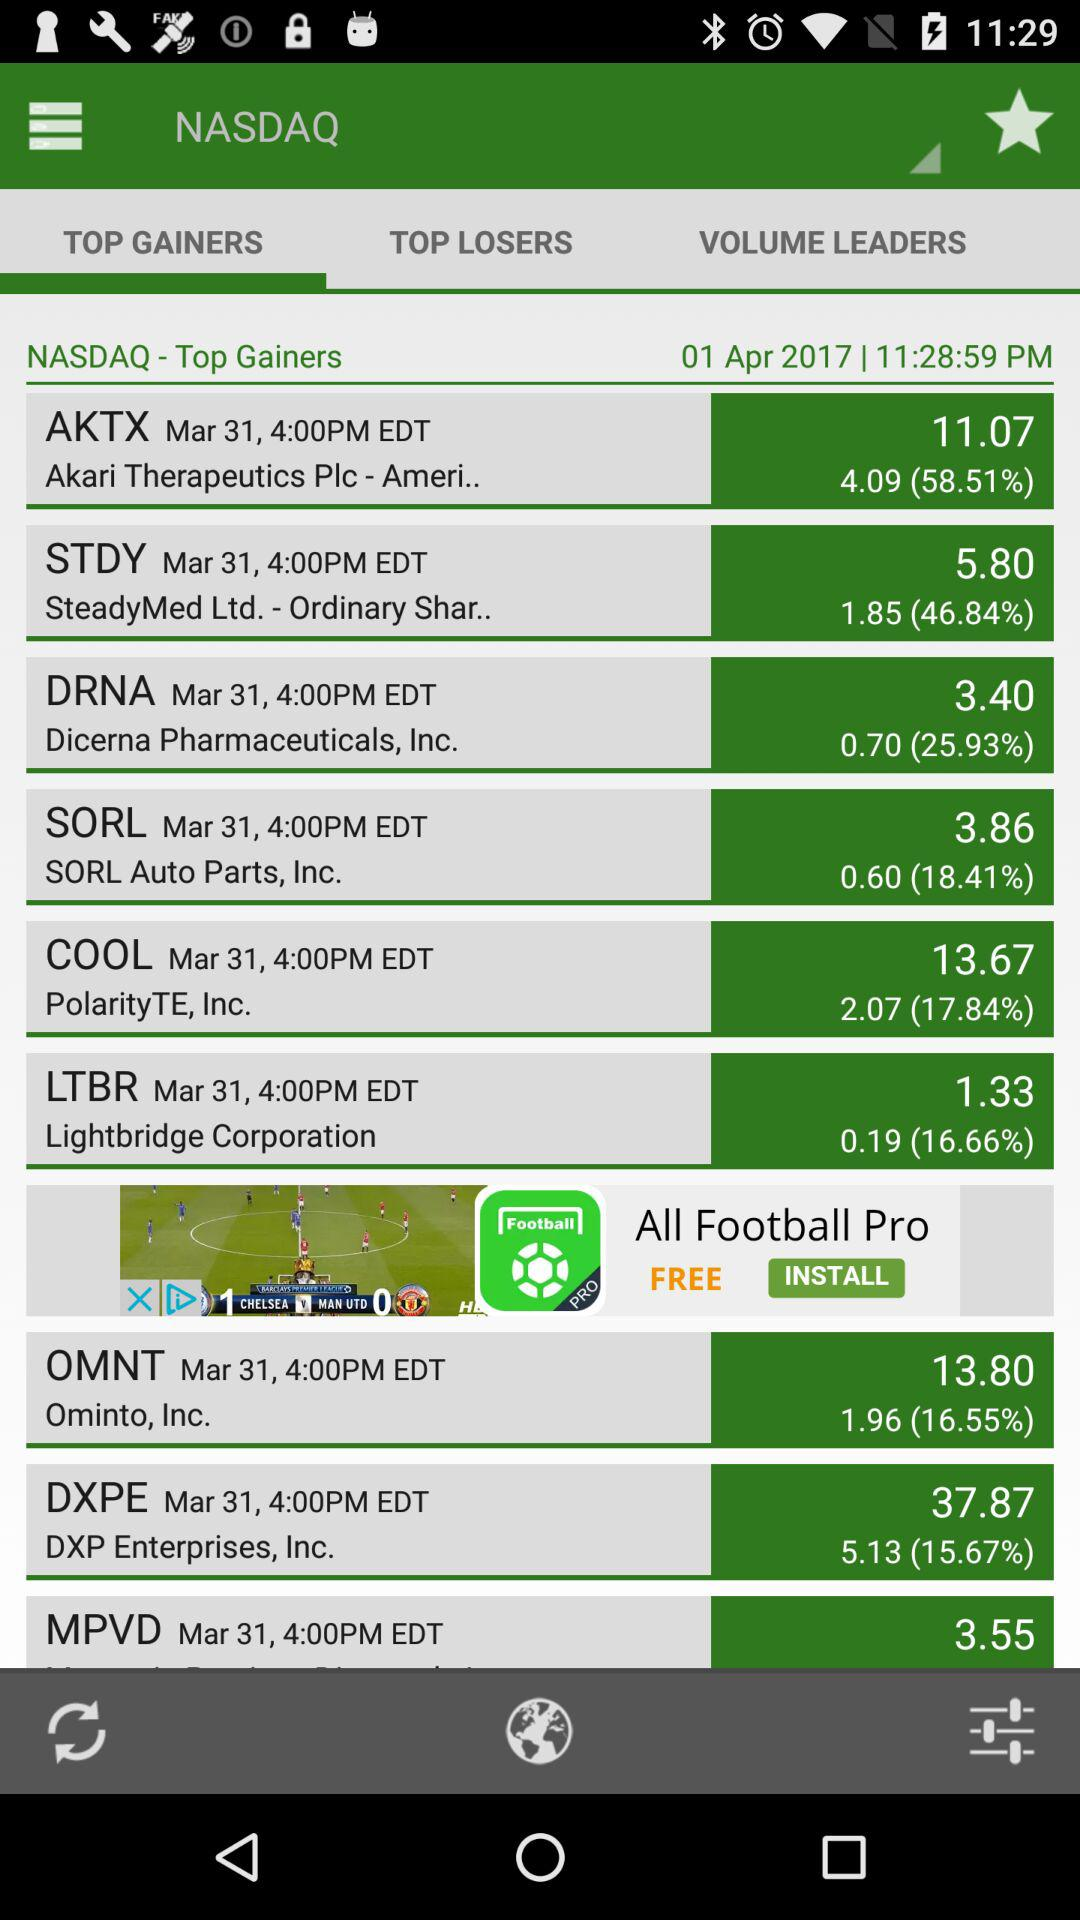What is the date of the last update? The date of the last update is April 1, 2017. 